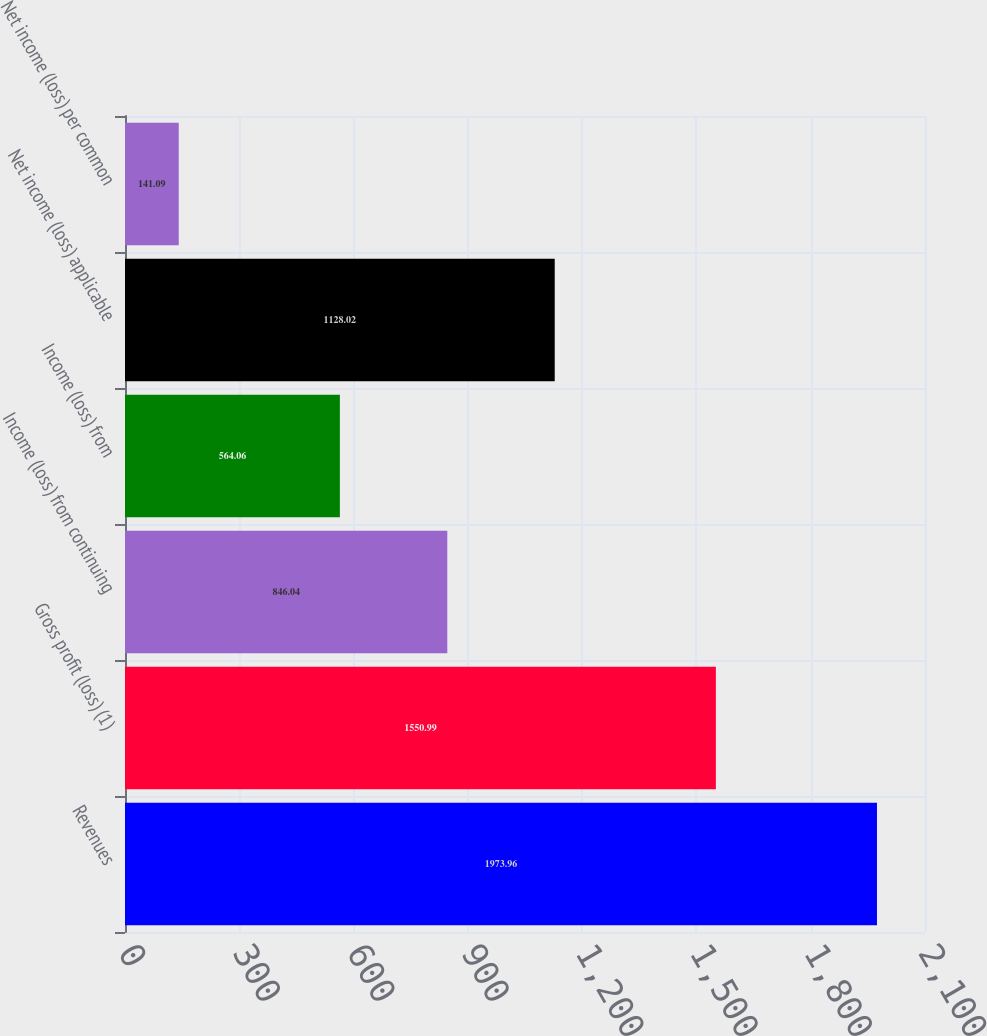Convert chart to OTSL. <chart><loc_0><loc_0><loc_500><loc_500><bar_chart><fcel>Revenues<fcel>Gross profit (loss) (1)<fcel>Income (loss) from continuing<fcel>Income (loss) from<fcel>Net income (loss) applicable<fcel>Net income (loss) per common<nl><fcel>1973.96<fcel>1550.99<fcel>846.04<fcel>564.06<fcel>1128.02<fcel>141.09<nl></chart> 